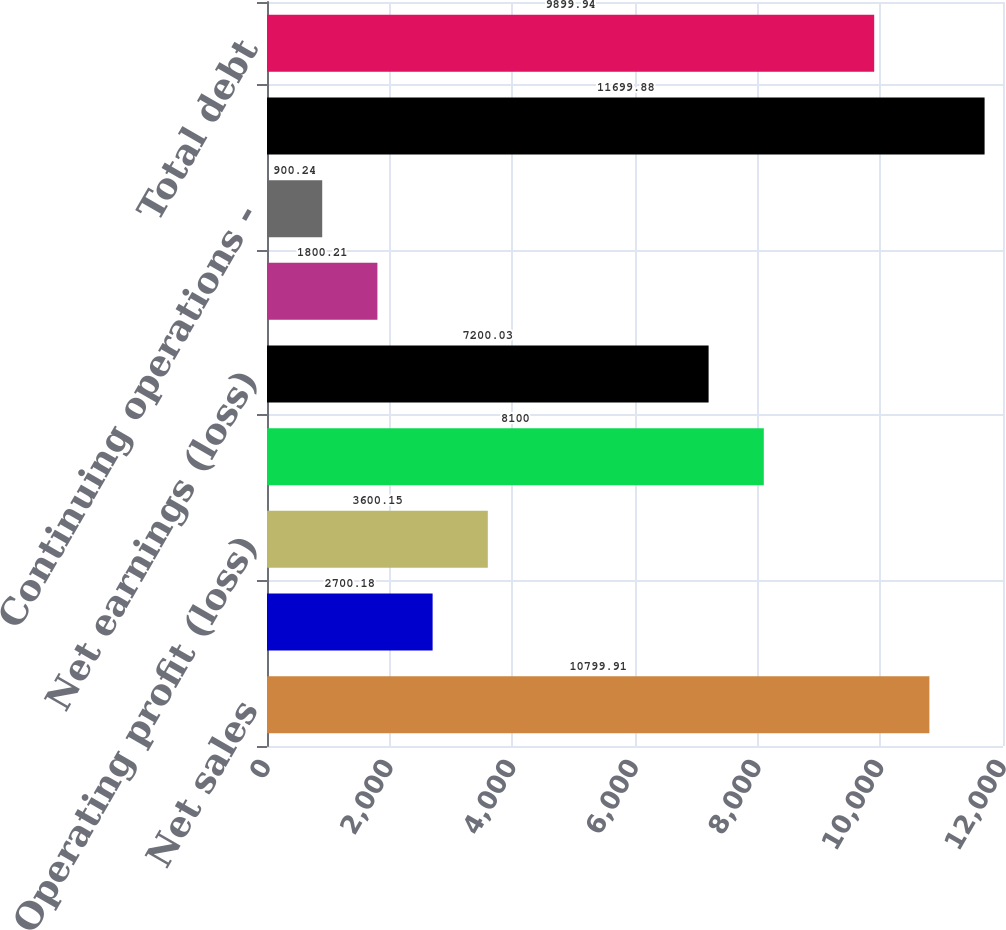<chart> <loc_0><loc_0><loc_500><loc_500><bar_chart><fcel>Net sales<fcel>Other (charges) gains net<fcel>Operating profit (loss)<fcel>Earnings (loss) from<fcel>Net earnings (loss)<fcel>Continuing operations - basic<fcel>Continuing operations -<fcel>Total assets<fcel>Total debt<nl><fcel>10799.9<fcel>2700.18<fcel>3600.15<fcel>8100<fcel>7200.03<fcel>1800.21<fcel>900.24<fcel>11699.9<fcel>9899.94<nl></chart> 